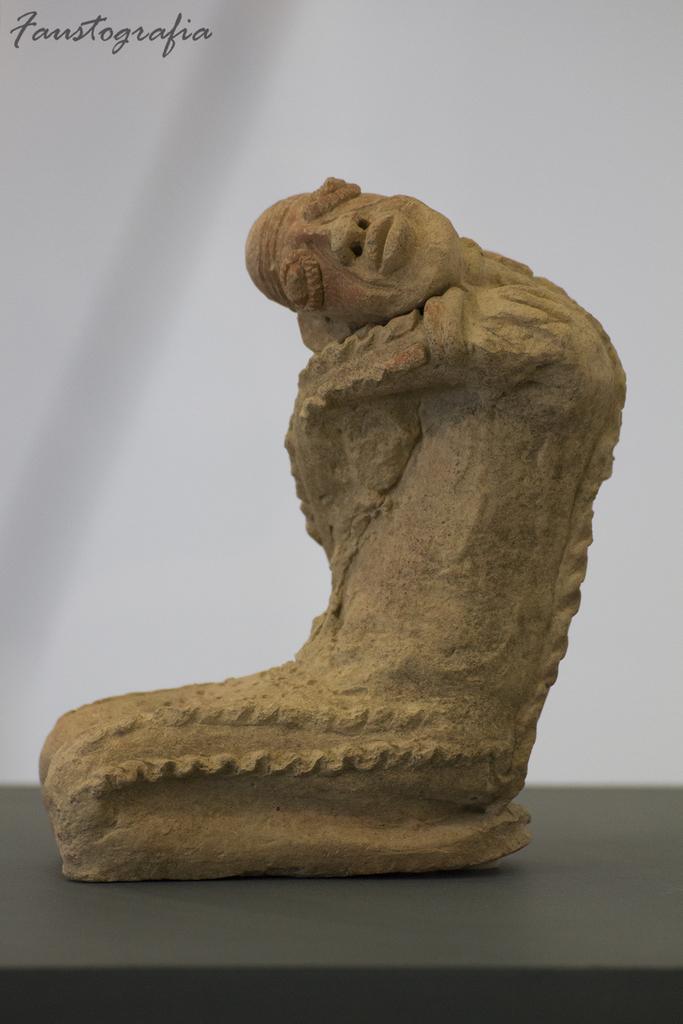How would you summarize this image in a sentence or two? In this image I can see a sculpture on a black color surface. Here I can see a watermark. The background of the image is white in color. 